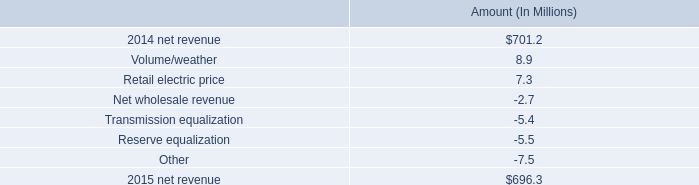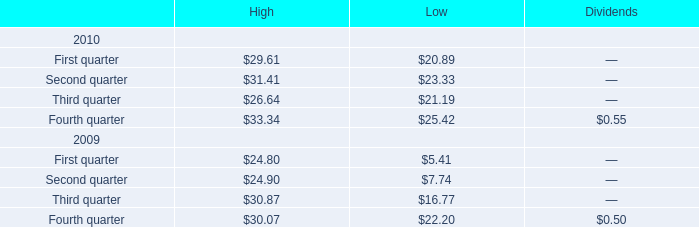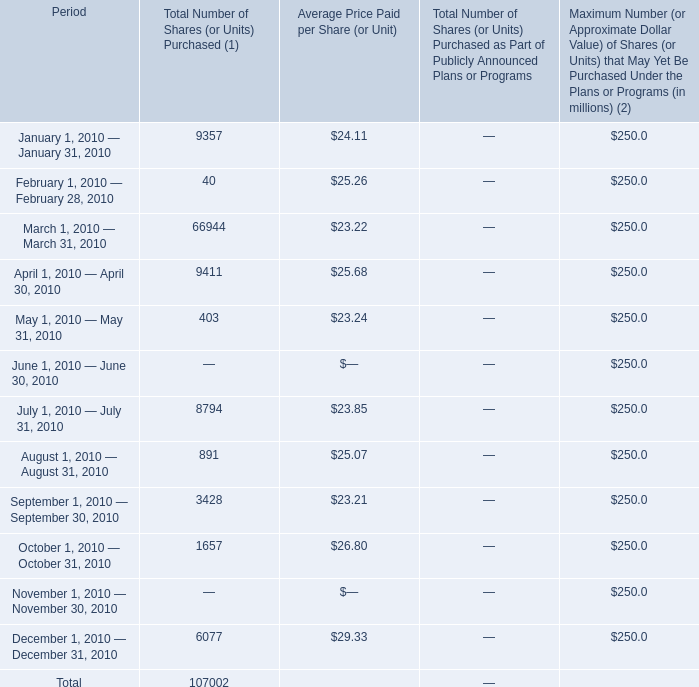In the year with lowest amount of Third quarter for high, what's the increasing rate of Fourth quarter for high? 
Computations: ((33.34 - 30.07) / 30.07)
Answer: 0.10875. 